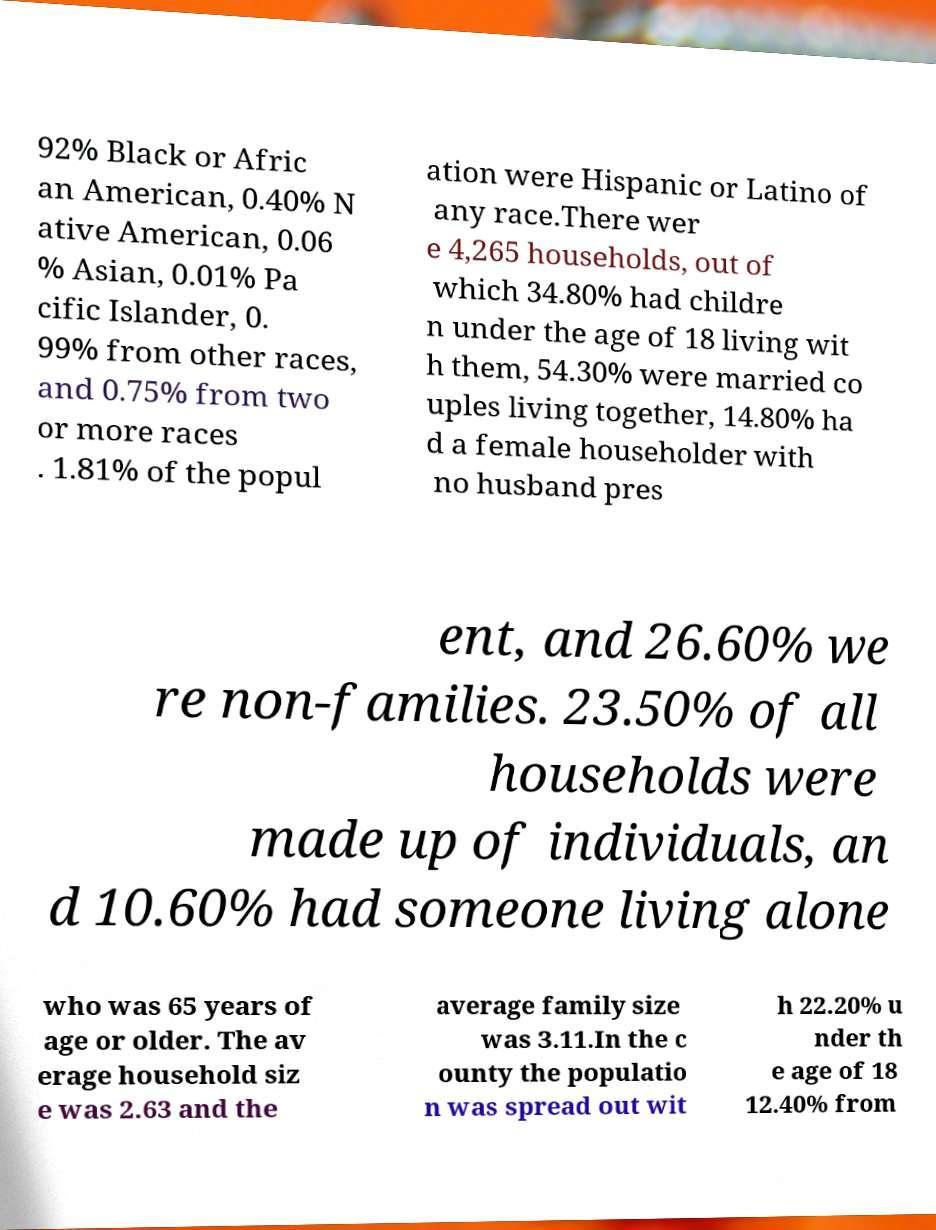There's text embedded in this image that I need extracted. Can you transcribe it verbatim? 92% Black or Afric an American, 0.40% N ative American, 0.06 % Asian, 0.01% Pa cific Islander, 0. 99% from other races, and 0.75% from two or more races . 1.81% of the popul ation were Hispanic or Latino of any race.There wer e 4,265 households, out of which 34.80% had childre n under the age of 18 living wit h them, 54.30% were married co uples living together, 14.80% ha d a female householder with no husband pres ent, and 26.60% we re non-families. 23.50% of all households were made up of individuals, an d 10.60% had someone living alone who was 65 years of age or older. The av erage household siz e was 2.63 and the average family size was 3.11.In the c ounty the populatio n was spread out wit h 22.20% u nder th e age of 18 12.40% from 